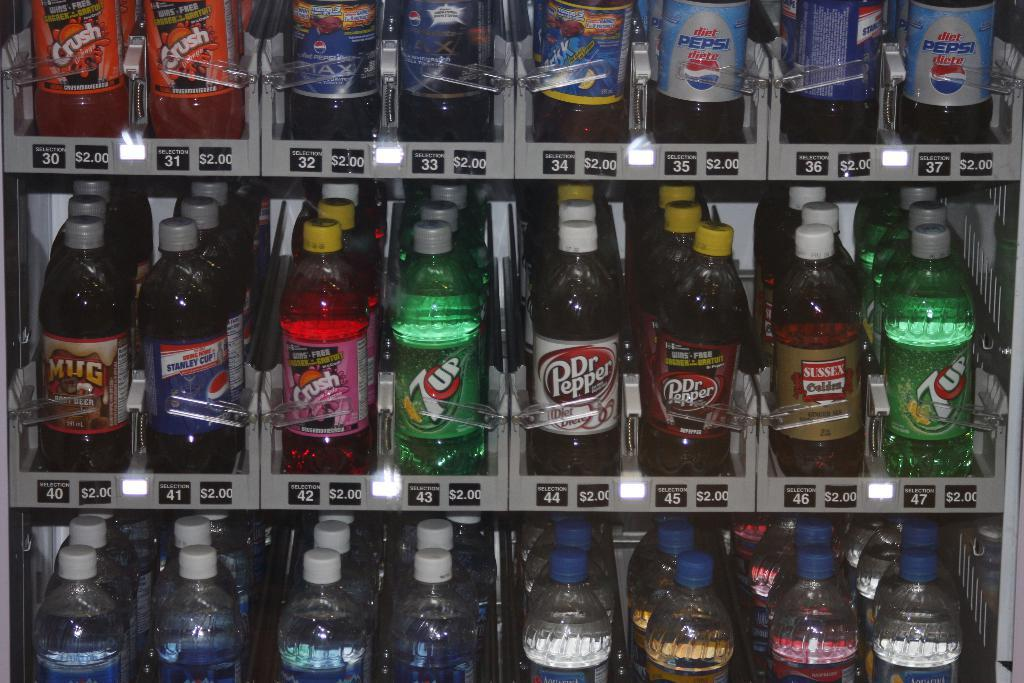<image>
Describe the image concisely. Bottles of soda including Crush and Pepsi are lined up. 